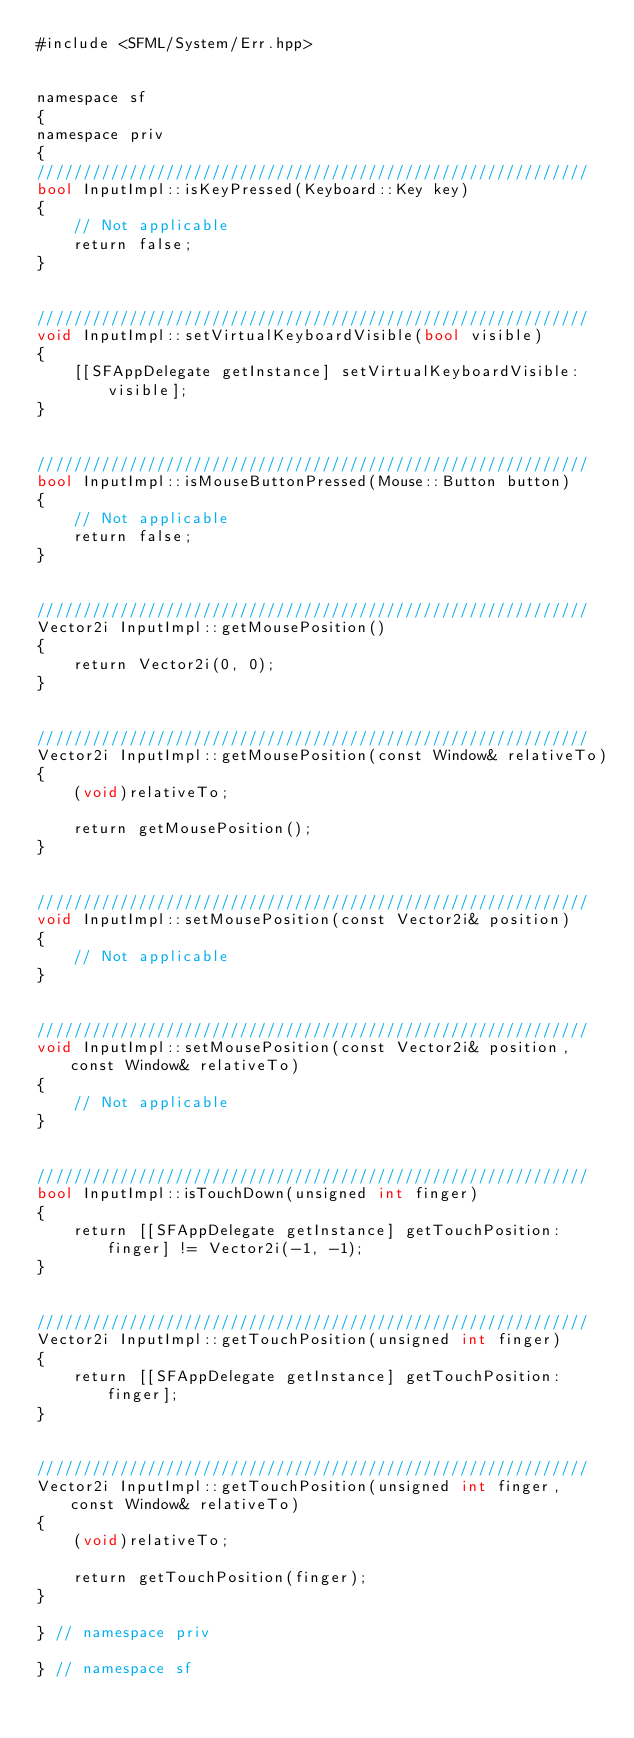<code> <loc_0><loc_0><loc_500><loc_500><_ObjectiveC_>#include <SFML/System/Err.hpp>


namespace sf
{
namespace priv
{
////////////////////////////////////////////////////////////
bool InputImpl::isKeyPressed(Keyboard::Key key)
{
    // Not applicable
    return false;
}


////////////////////////////////////////////////////////////
void InputImpl::setVirtualKeyboardVisible(bool visible)
{
    [[SFAppDelegate getInstance] setVirtualKeyboardVisible:visible];
}


////////////////////////////////////////////////////////////
bool InputImpl::isMouseButtonPressed(Mouse::Button button)
{
    // Not applicable
    return false;
}


////////////////////////////////////////////////////////////
Vector2i InputImpl::getMousePosition()
{
    return Vector2i(0, 0);
}


////////////////////////////////////////////////////////////
Vector2i InputImpl::getMousePosition(const Window& relativeTo)
{
    (void)relativeTo;

    return getMousePosition();
}


////////////////////////////////////////////////////////////
void InputImpl::setMousePosition(const Vector2i& position)
{
    // Not applicable
}


////////////////////////////////////////////////////////////
void InputImpl::setMousePosition(const Vector2i& position, const Window& relativeTo)
{
    // Not applicable
}


////////////////////////////////////////////////////////////
bool InputImpl::isTouchDown(unsigned int finger)
{
    return [[SFAppDelegate getInstance] getTouchPosition:finger] != Vector2i(-1, -1);
}


////////////////////////////////////////////////////////////
Vector2i InputImpl::getTouchPosition(unsigned int finger)
{
    return [[SFAppDelegate getInstance] getTouchPosition:finger];
}


////////////////////////////////////////////////////////////
Vector2i InputImpl::getTouchPosition(unsigned int finger, const Window& relativeTo)
{
    (void)relativeTo;

    return getTouchPosition(finger);
}

} // namespace priv

} // namespace sf
</code> 